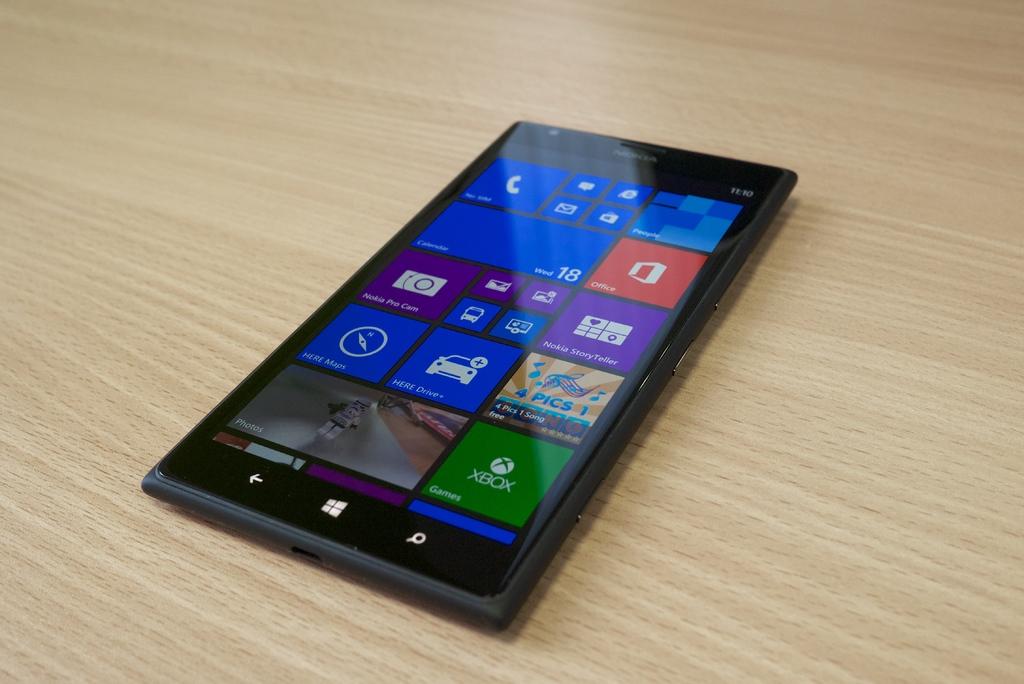Is there a photos tab?
Provide a succinct answer. Yes. 